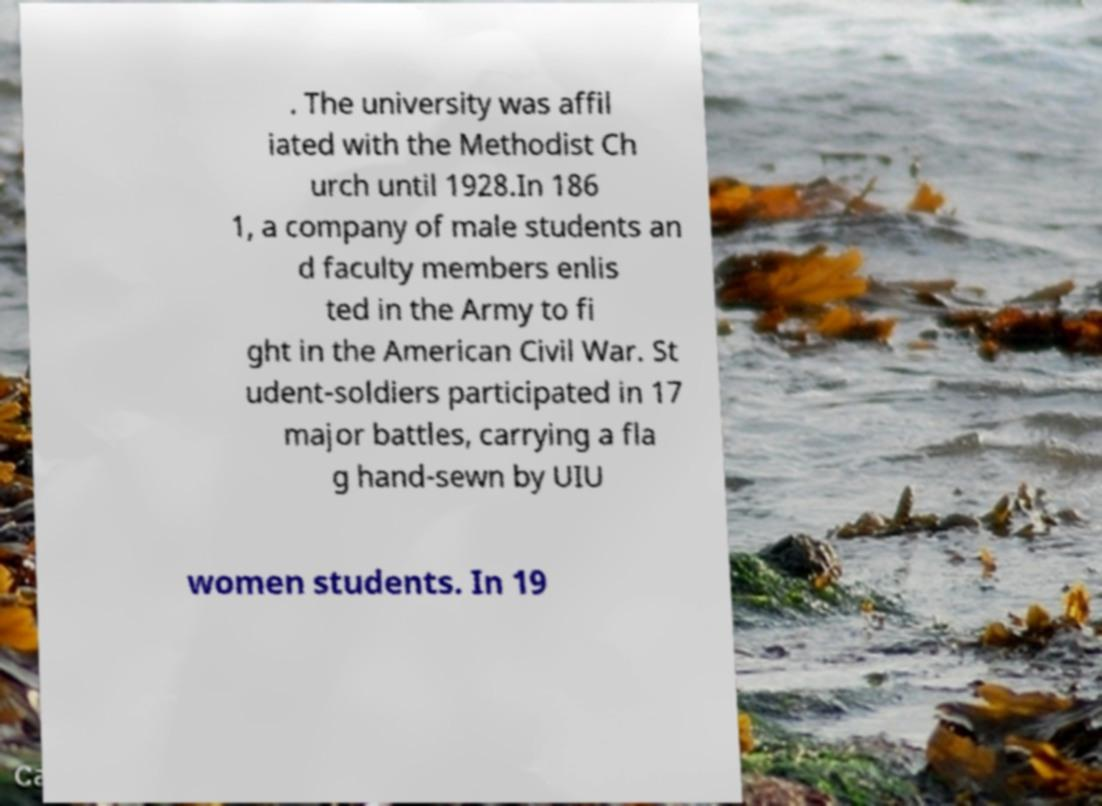There's text embedded in this image that I need extracted. Can you transcribe it verbatim? . The university was affil iated with the Methodist Ch urch until 1928.In 186 1, a company of male students an d faculty members enlis ted in the Army to fi ght in the American Civil War. St udent-soldiers participated in 17 major battles, carrying a fla g hand-sewn by UIU women students. In 19 